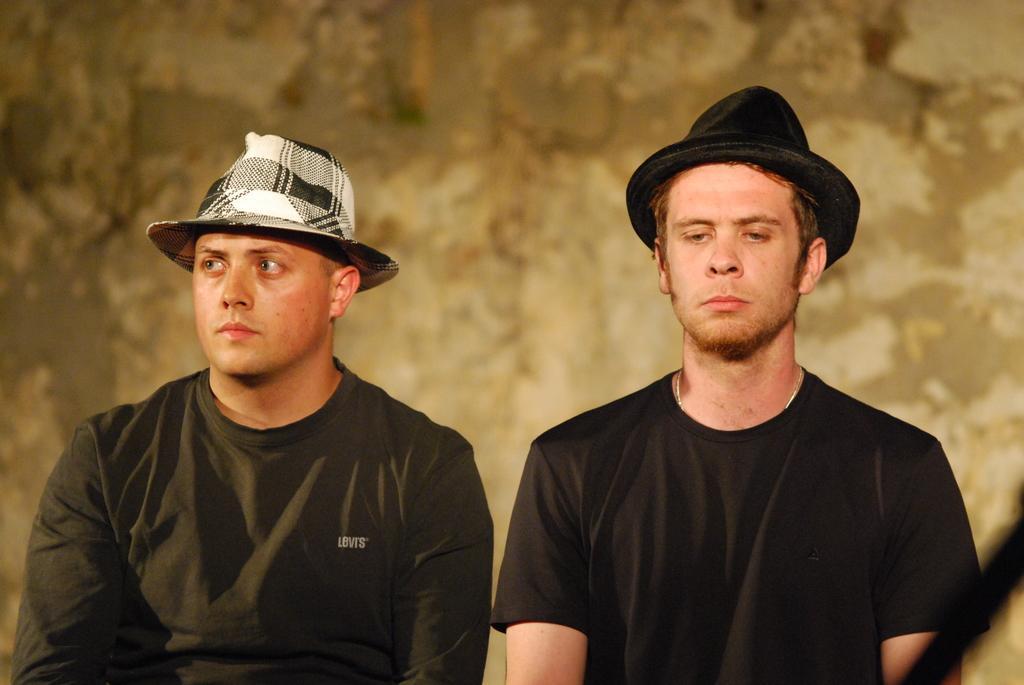How would you summarize this image in a sentence or two? In this picture I can see 2 men in front who are wearing hats and I see that both of them are wearing black color t-shirts and in the background I see the brown color thing. 